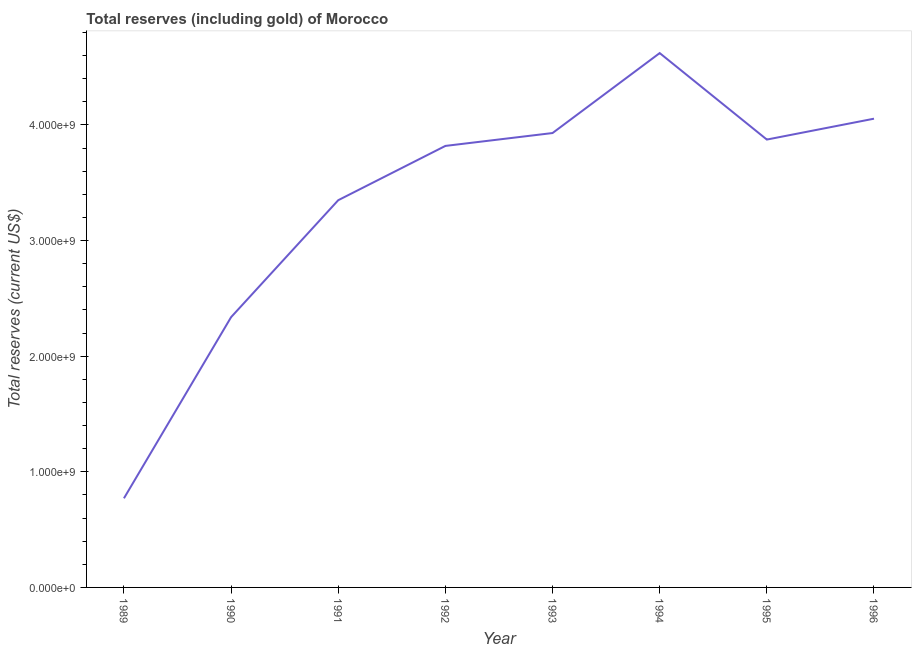What is the total reserves (including gold) in 1990?
Make the answer very short. 2.34e+09. Across all years, what is the maximum total reserves (including gold)?
Give a very brief answer. 4.62e+09. Across all years, what is the minimum total reserves (including gold)?
Make the answer very short. 7.71e+08. What is the sum of the total reserves (including gold)?
Offer a terse response. 2.68e+1. What is the difference between the total reserves (including gold) in 1990 and 1993?
Your answer should be very brief. -1.59e+09. What is the average total reserves (including gold) per year?
Give a very brief answer. 3.34e+09. What is the median total reserves (including gold)?
Your answer should be very brief. 3.85e+09. What is the ratio of the total reserves (including gold) in 1990 to that in 1994?
Your answer should be very brief. 0.51. What is the difference between the highest and the second highest total reserves (including gold)?
Your response must be concise. 5.67e+08. Is the sum of the total reserves (including gold) in 1991 and 1996 greater than the maximum total reserves (including gold) across all years?
Your answer should be very brief. Yes. What is the difference between the highest and the lowest total reserves (including gold)?
Your response must be concise. 3.85e+09. In how many years, is the total reserves (including gold) greater than the average total reserves (including gold) taken over all years?
Offer a terse response. 6. What is the difference between two consecutive major ticks on the Y-axis?
Offer a terse response. 1.00e+09. Are the values on the major ticks of Y-axis written in scientific E-notation?
Provide a succinct answer. Yes. What is the title of the graph?
Your answer should be compact. Total reserves (including gold) of Morocco. What is the label or title of the X-axis?
Provide a succinct answer. Year. What is the label or title of the Y-axis?
Keep it short and to the point. Total reserves (current US$). What is the Total reserves (current US$) in 1989?
Ensure brevity in your answer.  7.71e+08. What is the Total reserves (current US$) in 1990?
Your answer should be very brief. 2.34e+09. What is the Total reserves (current US$) of 1991?
Offer a terse response. 3.35e+09. What is the Total reserves (current US$) of 1992?
Keep it short and to the point. 3.82e+09. What is the Total reserves (current US$) in 1993?
Your response must be concise. 3.93e+09. What is the Total reserves (current US$) in 1994?
Your response must be concise. 4.62e+09. What is the Total reserves (current US$) in 1995?
Make the answer very short. 3.87e+09. What is the Total reserves (current US$) in 1996?
Your response must be concise. 4.05e+09. What is the difference between the Total reserves (current US$) in 1989 and 1990?
Provide a short and direct response. -1.57e+09. What is the difference between the Total reserves (current US$) in 1989 and 1991?
Make the answer very short. -2.58e+09. What is the difference between the Total reserves (current US$) in 1989 and 1992?
Provide a succinct answer. -3.05e+09. What is the difference between the Total reserves (current US$) in 1989 and 1993?
Offer a terse response. -3.16e+09. What is the difference between the Total reserves (current US$) in 1989 and 1994?
Keep it short and to the point. -3.85e+09. What is the difference between the Total reserves (current US$) in 1989 and 1995?
Provide a succinct answer. -3.10e+09. What is the difference between the Total reserves (current US$) in 1989 and 1996?
Ensure brevity in your answer.  -3.28e+09. What is the difference between the Total reserves (current US$) in 1990 and 1991?
Provide a succinct answer. -1.01e+09. What is the difference between the Total reserves (current US$) in 1990 and 1992?
Ensure brevity in your answer.  -1.48e+09. What is the difference between the Total reserves (current US$) in 1990 and 1993?
Your answer should be compact. -1.59e+09. What is the difference between the Total reserves (current US$) in 1990 and 1994?
Your response must be concise. -2.28e+09. What is the difference between the Total reserves (current US$) in 1990 and 1995?
Keep it short and to the point. -1.54e+09. What is the difference between the Total reserves (current US$) in 1990 and 1996?
Provide a succinct answer. -1.72e+09. What is the difference between the Total reserves (current US$) in 1991 and 1992?
Give a very brief answer. -4.70e+08. What is the difference between the Total reserves (current US$) in 1991 and 1993?
Provide a short and direct response. -5.81e+08. What is the difference between the Total reserves (current US$) in 1991 and 1994?
Offer a very short reply. -1.27e+09. What is the difference between the Total reserves (current US$) in 1991 and 1995?
Make the answer very short. -5.24e+08. What is the difference between the Total reserves (current US$) in 1991 and 1996?
Make the answer very short. -7.05e+08. What is the difference between the Total reserves (current US$) in 1992 and 1993?
Give a very brief answer. -1.11e+08. What is the difference between the Total reserves (current US$) in 1992 and 1994?
Keep it short and to the point. -8.03e+08. What is the difference between the Total reserves (current US$) in 1992 and 1995?
Ensure brevity in your answer.  -5.49e+07. What is the difference between the Total reserves (current US$) in 1992 and 1996?
Offer a very short reply. -2.35e+08. What is the difference between the Total reserves (current US$) in 1993 and 1994?
Provide a succinct answer. -6.92e+08. What is the difference between the Total reserves (current US$) in 1993 and 1995?
Provide a succinct answer. 5.64e+07. What is the difference between the Total reserves (current US$) in 1993 and 1996?
Make the answer very short. -1.24e+08. What is the difference between the Total reserves (current US$) in 1994 and 1995?
Ensure brevity in your answer.  7.48e+08. What is the difference between the Total reserves (current US$) in 1994 and 1996?
Provide a succinct answer. 5.67e+08. What is the difference between the Total reserves (current US$) in 1995 and 1996?
Your answer should be very brief. -1.81e+08. What is the ratio of the Total reserves (current US$) in 1989 to that in 1990?
Make the answer very short. 0.33. What is the ratio of the Total reserves (current US$) in 1989 to that in 1991?
Offer a very short reply. 0.23. What is the ratio of the Total reserves (current US$) in 1989 to that in 1992?
Give a very brief answer. 0.2. What is the ratio of the Total reserves (current US$) in 1989 to that in 1993?
Keep it short and to the point. 0.2. What is the ratio of the Total reserves (current US$) in 1989 to that in 1994?
Provide a succinct answer. 0.17. What is the ratio of the Total reserves (current US$) in 1989 to that in 1995?
Your answer should be compact. 0.2. What is the ratio of the Total reserves (current US$) in 1989 to that in 1996?
Offer a terse response. 0.19. What is the ratio of the Total reserves (current US$) in 1990 to that in 1991?
Ensure brevity in your answer.  0.7. What is the ratio of the Total reserves (current US$) in 1990 to that in 1992?
Your answer should be compact. 0.61. What is the ratio of the Total reserves (current US$) in 1990 to that in 1993?
Keep it short and to the point. 0.59. What is the ratio of the Total reserves (current US$) in 1990 to that in 1994?
Ensure brevity in your answer.  0.51. What is the ratio of the Total reserves (current US$) in 1990 to that in 1995?
Ensure brevity in your answer.  0.6. What is the ratio of the Total reserves (current US$) in 1990 to that in 1996?
Offer a terse response. 0.58. What is the ratio of the Total reserves (current US$) in 1991 to that in 1992?
Your answer should be compact. 0.88. What is the ratio of the Total reserves (current US$) in 1991 to that in 1993?
Provide a succinct answer. 0.85. What is the ratio of the Total reserves (current US$) in 1991 to that in 1994?
Provide a succinct answer. 0.72. What is the ratio of the Total reserves (current US$) in 1991 to that in 1995?
Offer a very short reply. 0.86. What is the ratio of the Total reserves (current US$) in 1991 to that in 1996?
Make the answer very short. 0.83. What is the ratio of the Total reserves (current US$) in 1992 to that in 1993?
Keep it short and to the point. 0.97. What is the ratio of the Total reserves (current US$) in 1992 to that in 1994?
Offer a very short reply. 0.83. What is the ratio of the Total reserves (current US$) in 1992 to that in 1996?
Provide a succinct answer. 0.94. What is the ratio of the Total reserves (current US$) in 1993 to that in 1994?
Make the answer very short. 0.85. What is the ratio of the Total reserves (current US$) in 1994 to that in 1995?
Make the answer very short. 1.19. What is the ratio of the Total reserves (current US$) in 1994 to that in 1996?
Your response must be concise. 1.14. What is the ratio of the Total reserves (current US$) in 1995 to that in 1996?
Offer a terse response. 0.95. 